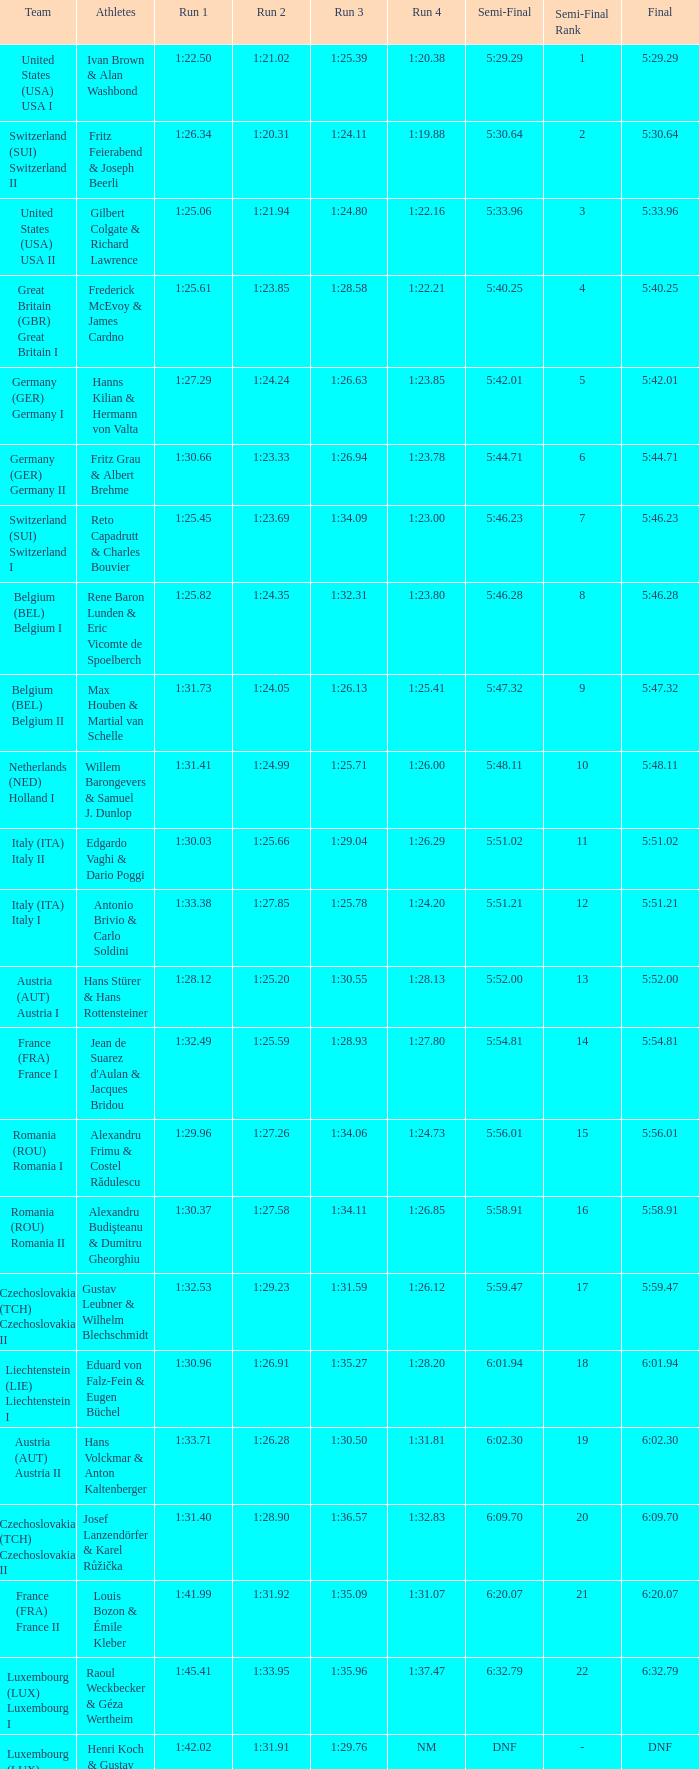Which Run 4 has a Run 3 of 1:26.63? 1:23.85. 